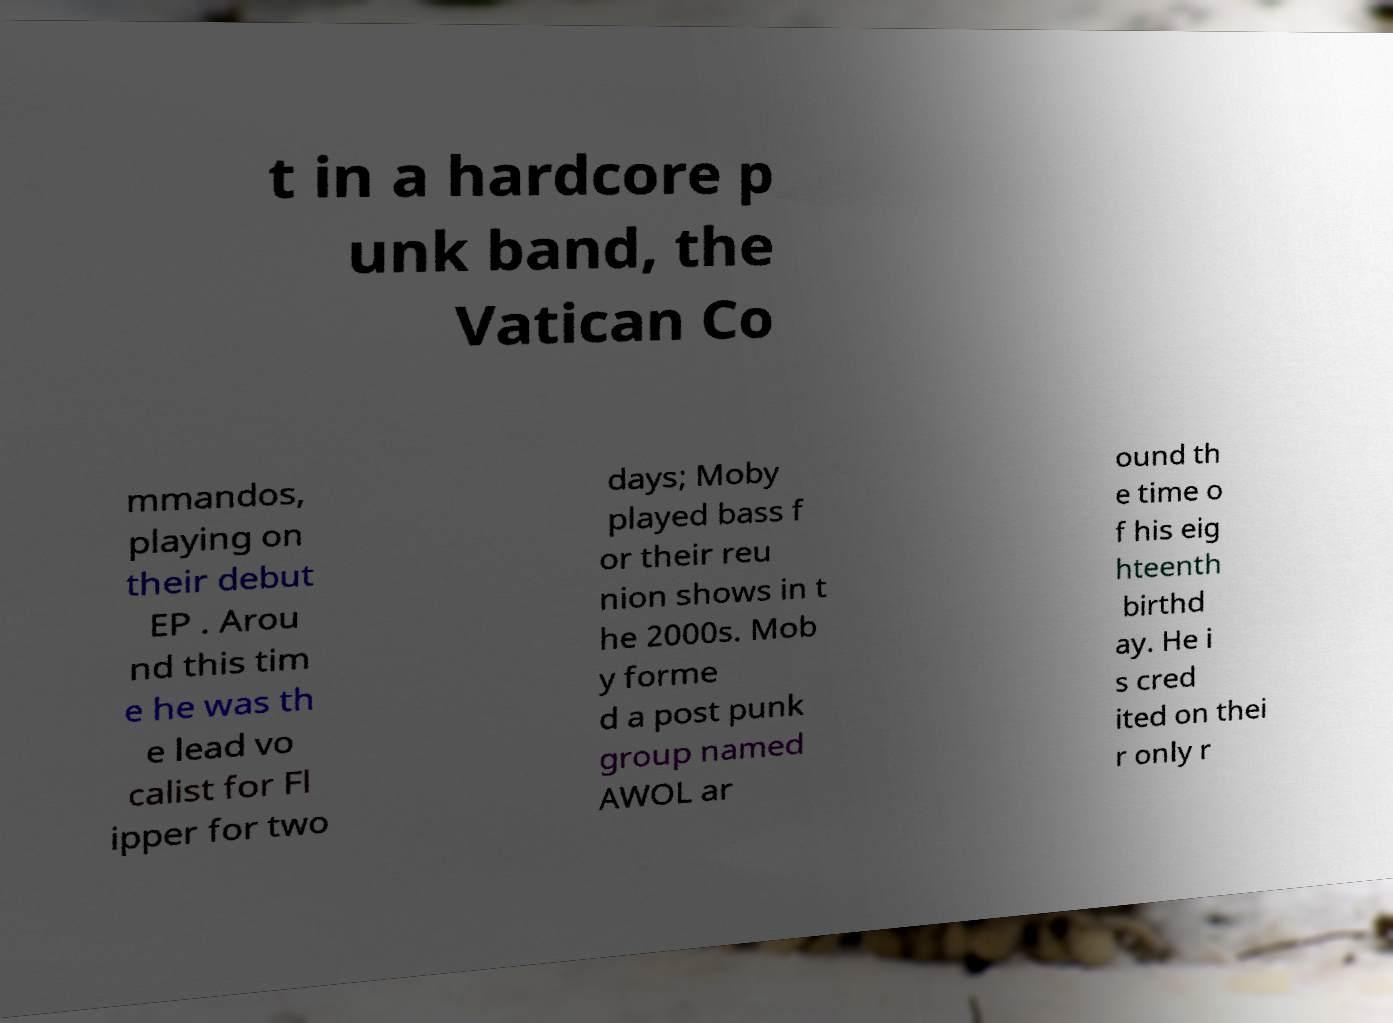Please identify and transcribe the text found in this image. t in a hardcore p unk band, the Vatican Co mmandos, playing on their debut EP . Arou nd this tim e he was th e lead vo calist for Fl ipper for two days; Moby played bass f or their reu nion shows in t he 2000s. Mob y forme d a post punk group named AWOL ar ound th e time o f his eig hteenth birthd ay. He i s cred ited on thei r only r 